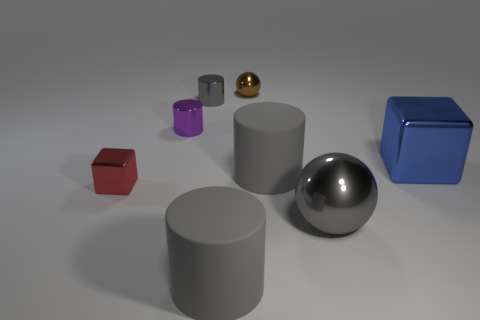How many gray cylinders must be subtracted to get 1 gray cylinders? 2 Subtract all brown spheres. How many gray cylinders are left? 3 Add 2 purple shiny cylinders. How many objects exist? 10 Subtract all yellow cylinders. Subtract all yellow cubes. How many cylinders are left? 4 Subtract all spheres. How many objects are left? 6 Subtract all gray spheres. Subtract all brown metal objects. How many objects are left? 6 Add 2 small red metal cubes. How many small red metal cubes are left? 3 Add 8 small purple objects. How many small purple objects exist? 9 Subtract 0 cyan cylinders. How many objects are left? 8 